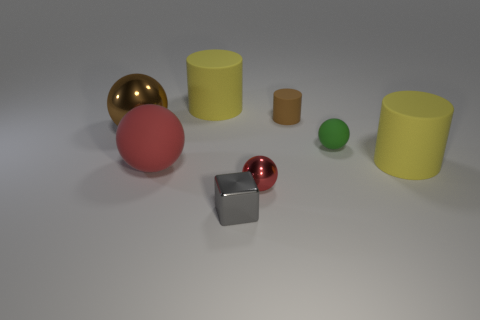Subtract all yellow cylinders. How many cylinders are left? 1 Subtract all green spheres. How many spheres are left? 3 Add 1 brown spheres. How many objects exist? 9 Subtract all cyan spheres. Subtract all brown cubes. How many spheres are left? 4 Subtract all cylinders. How many objects are left? 5 Add 5 rubber spheres. How many rubber spheres exist? 7 Subtract 1 gray cubes. How many objects are left? 7 Subtract all metallic objects. Subtract all cubes. How many objects are left? 4 Add 7 big metal balls. How many big metal balls are left? 8 